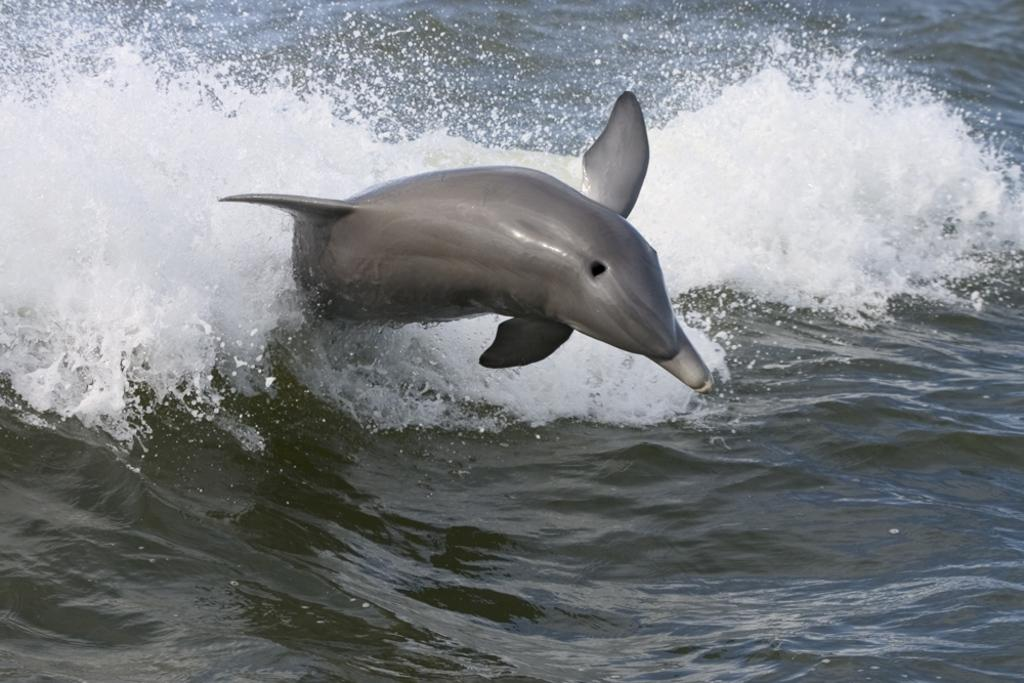What animal is present in the image? There is a dolphin in the image. What is the dolphin doing in the image? The dolphin is jumping in water. What type of basket is the dolphin using to jump in the image? There is no basket present in the image, and the dolphin is not using any basket to jump. What language is the dolphin speaking while jumping in the image? Dolphins do not speak human languages, and there is no indication in the image that the dolphin is speaking any language. 